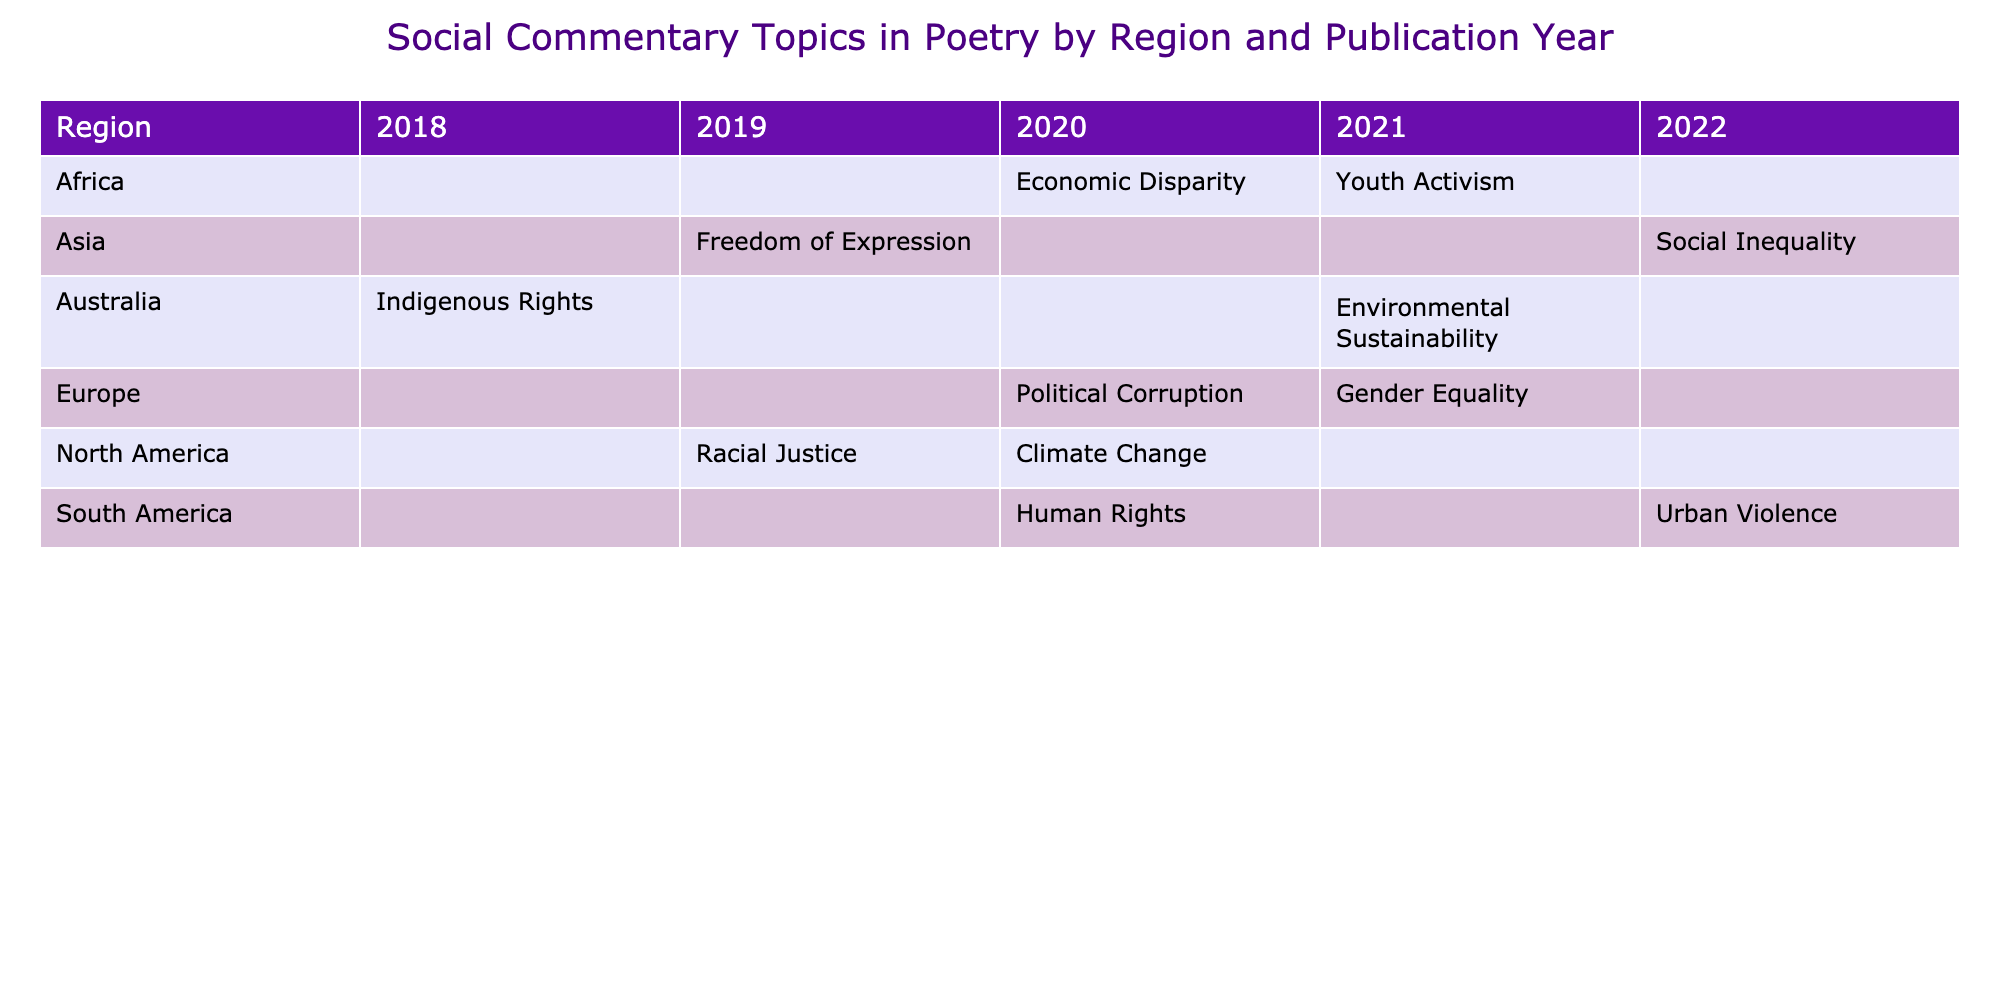What social commentary topic was addressed in the publication year 2020 for Asia? In the table, we look under the Asia row for the publication year 2020, where the topic listed is "Freedom of Expression."
Answer: Freedom of Expression Which region had the most diverse range of social commentary topics in the year 2021? By examining the year 2021 across regions, we see that Asia, Africa, and Europe all present distinct topics. North America only has "Climate Change." Thus, the answer requires a count of distinct topics mentioned, leading to a conclusion that Asia, Africa, and Europe each contribute uniquely in 2021.
Answer: Three regions Is "Youth Activism" a social commentary topic addressed in Africa? Acknowledging the table, we note that "Youth Activism" is explicitly mentioned under the Africa row in the year 2021, confirming the topic was indeed addressed.
Answer: Yes How many social commentary topics were published in Australia between 2018 and 2021? By reviewing the table for the Australia section, two distinct topics are stated: "Indigenous Rights" in 2018 and "Environmental Sustainability" in 2021. Thus, when combining these entries, we find two social commentary topics published during this period.
Answer: Two topics Did the year 2019 see any topics concerning Economic Disparity in North America? Upon scrutiny of the North America section for the year 2019, we notice "Racial Justice" is addressed, while there’s no mention of Economic Disparity. Therefore, the answer can clearly be determined.
Answer: No Which social commentary topic is not mentioned in any publication from South America? Looking across the South America section, we see that topics like "Human Rights" and "Urban Violence" are specified. Checking each, we can conclude that "Economic Disparity" is missing from this region’s topics, directly addressing the query.
Answer: Economic Disparity What is the total number of distinct social commentary topics discussed across all regions for the year 2021? In 2021, the topics listed per region include: "Gender Equality" (Europe), "Youth Activism" (Africa), and "Environmental Sustainability" (Australia). This yields three unique topics, while others do not mention that year. Thus, compiling this information leads to the total.
Answer: Three topics In which region and publication year did the topic of "Political Corruption" emerge? By scanning the table for the entry of "Political Corruption," one sees it is listed under Europe for the year 2020, confirming exactly where the topic appeared.
Answer: Europe, 2020 Which notable poet or playwright is associated with the topic of "Urban Violence" from South America? The table presents that "Urban Violence" is associated with Marcos Siscar in South America for the year 2022, providing a direct correspondence between the topic and an individual.
Answer: Marcos Siscar 